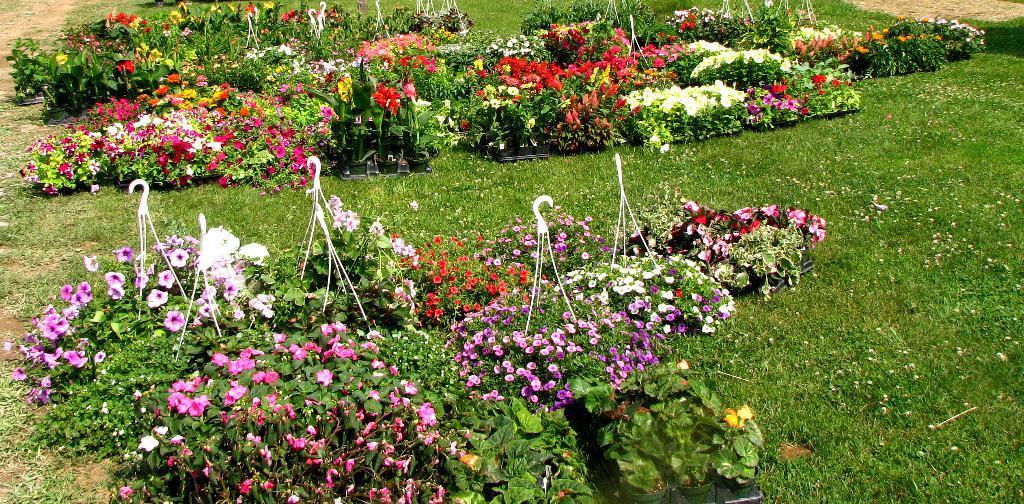How would you summarize this image in a sentence or two? In the image we can see some plants, flowers and grass. 